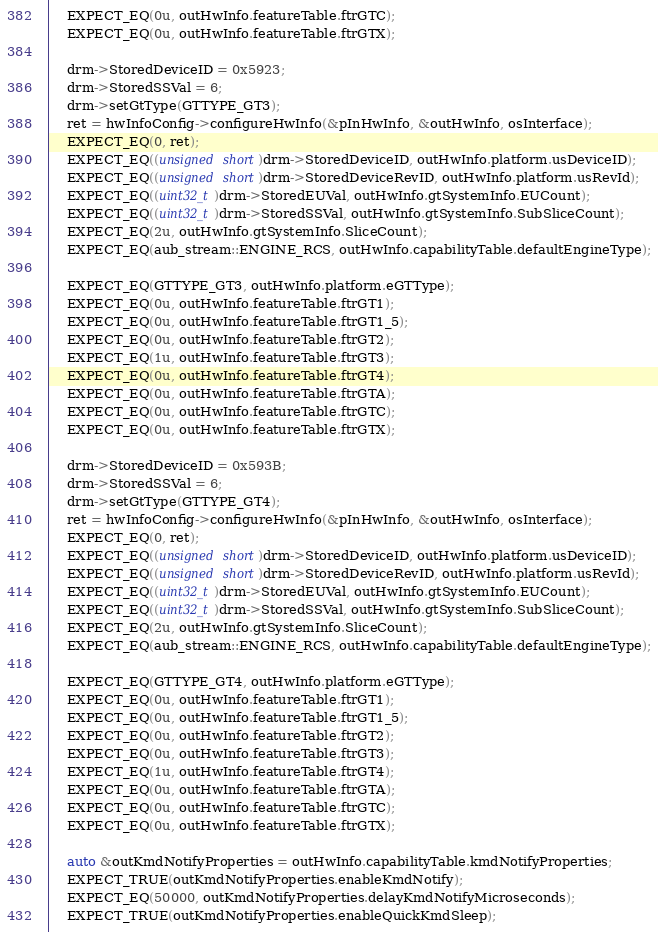Convert code to text. <code><loc_0><loc_0><loc_500><loc_500><_C++_>    EXPECT_EQ(0u, outHwInfo.featureTable.ftrGTC);
    EXPECT_EQ(0u, outHwInfo.featureTable.ftrGTX);

    drm->StoredDeviceID = 0x5923;
    drm->StoredSSVal = 6;
    drm->setGtType(GTTYPE_GT3);
    ret = hwInfoConfig->configureHwInfo(&pInHwInfo, &outHwInfo, osInterface);
    EXPECT_EQ(0, ret);
    EXPECT_EQ((unsigned short)drm->StoredDeviceID, outHwInfo.platform.usDeviceID);
    EXPECT_EQ((unsigned short)drm->StoredDeviceRevID, outHwInfo.platform.usRevId);
    EXPECT_EQ((uint32_t)drm->StoredEUVal, outHwInfo.gtSystemInfo.EUCount);
    EXPECT_EQ((uint32_t)drm->StoredSSVal, outHwInfo.gtSystemInfo.SubSliceCount);
    EXPECT_EQ(2u, outHwInfo.gtSystemInfo.SliceCount);
    EXPECT_EQ(aub_stream::ENGINE_RCS, outHwInfo.capabilityTable.defaultEngineType);

    EXPECT_EQ(GTTYPE_GT3, outHwInfo.platform.eGTType);
    EXPECT_EQ(0u, outHwInfo.featureTable.ftrGT1);
    EXPECT_EQ(0u, outHwInfo.featureTable.ftrGT1_5);
    EXPECT_EQ(0u, outHwInfo.featureTable.ftrGT2);
    EXPECT_EQ(1u, outHwInfo.featureTable.ftrGT3);
    EXPECT_EQ(0u, outHwInfo.featureTable.ftrGT4);
    EXPECT_EQ(0u, outHwInfo.featureTable.ftrGTA);
    EXPECT_EQ(0u, outHwInfo.featureTable.ftrGTC);
    EXPECT_EQ(0u, outHwInfo.featureTable.ftrGTX);

    drm->StoredDeviceID = 0x593B;
    drm->StoredSSVal = 6;
    drm->setGtType(GTTYPE_GT4);
    ret = hwInfoConfig->configureHwInfo(&pInHwInfo, &outHwInfo, osInterface);
    EXPECT_EQ(0, ret);
    EXPECT_EQ((unsigned short)drm->StoredDeviceID, outHwInfo.platform.usDeviceID);
    EXPECT_EQ((unsigned short)drm->StoredDeviceRevID, outHwInfo.platform.usRevId);
    EXPECT_EQ((uint32_t)drm->StoredEUVal, outHwInfo.gtSystemInfo.EUCount);
    EXPECT_EQ((uint32_t)drm->StoredSSVal, outHwInfo.gtSystemInfo.SubSliceCount);
    EXPECT_EQ(2u, outHwInfo.gtSystemInfo.SliceCount);
    EXPECT_EQ(aub_stream::ENGINE_RCS, outHwInfo.capabilityTable.defaultEngineType);

    EXPECT_EQ(GTTYPE_GT4, outHwInfo.platform.eGTType);
    EXPECT_EQ(0u, outHwInfo.featureTable.ftrGT1);
    EXPECT_EQ(0u, outHwInfo.featureTable.ftrGT1_5);
    EXPECT_EQ(0u, outHwInfo.featureTable.ftrGT2);
    EXPECT_EQ(0u, outHwInfo.featureTable.ftrGT3);
    EXPECT_EQ(1u, outHwInfo.featureTable.ftrGT4);
    EXPECT_EQ(0u, outHwInfo.featureTable.ftrGTA);
    EXPECT_EQ(0u, outHwInfo.featureTable.ftrGTC);
    EXPECT_EQ(0u, outHwInfo.featureTable.ftrGTX);

    auto &outKmdNotifyProperties = outHwInfo.capabilityTable.kmdNotifyProperties;
    EXPECT_TRUE(outKmdNotifyProperties.enableKmdNotify);
    EXPECT_EQ(50000, outKmdNotifyProperties.delayKmdNotifyMicroseconds);
    EXPECT_TRUE(outKmdNotifyProperties.enableQuickKmdSleep);</code> 